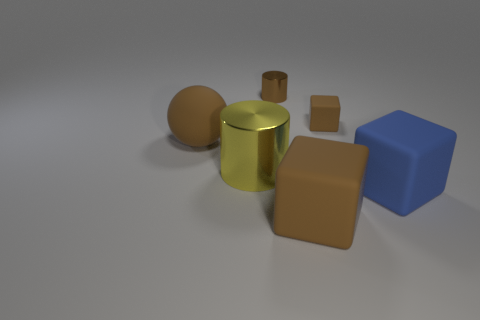Add 4 small brown matte things. How many objects exist? 10 Subtract all cylinders. How many objects are left? 4 Add 5 brown balls. How many brown balls exist? 6 Subtract 0 blue spheres. How many objects are left? 6 Subtract all matte things. Subtract all small brown shiny things. How many objects are left? 1 Add 4 big cubes. How many big cubes are left? 6 